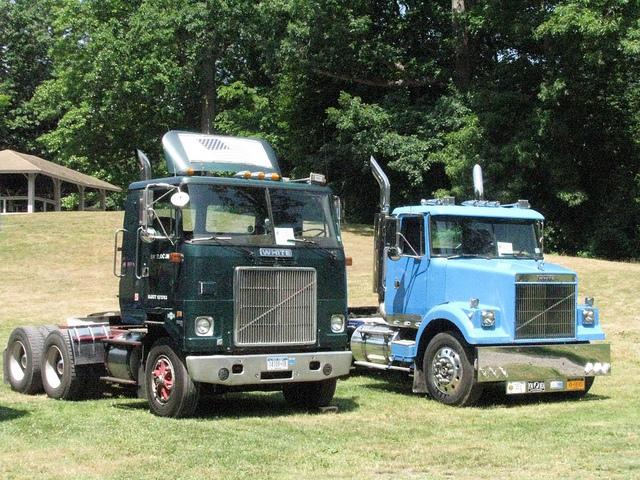How many wheels does the green truck have?
Give a very brief answer. 10. Do these trunks have trailers attached to the back of them?
Give a very brief answer. No. How many windshield wipers are there?
Quick response, please. 4. Is this a landscaping truck?
Short answer required. No. What is the color of the truck next to the green truck?
Keep it brief. Blue. Who is driving the truck?
Concise answer only. No one. 